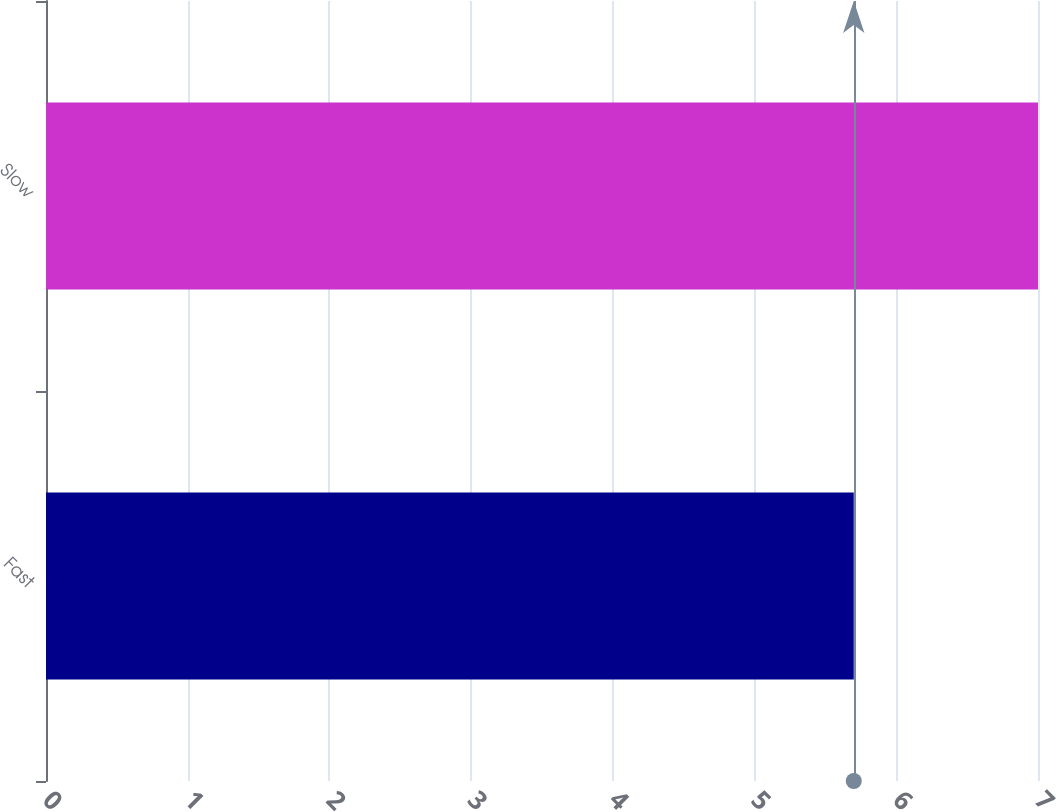Convert chart. <chart><loc_0><loc_0><loc_500><loc_500><bar_chart><fcel>Fast<fcel>Slow<nl><fcel>5.7<fcel>7<nl></chart> 